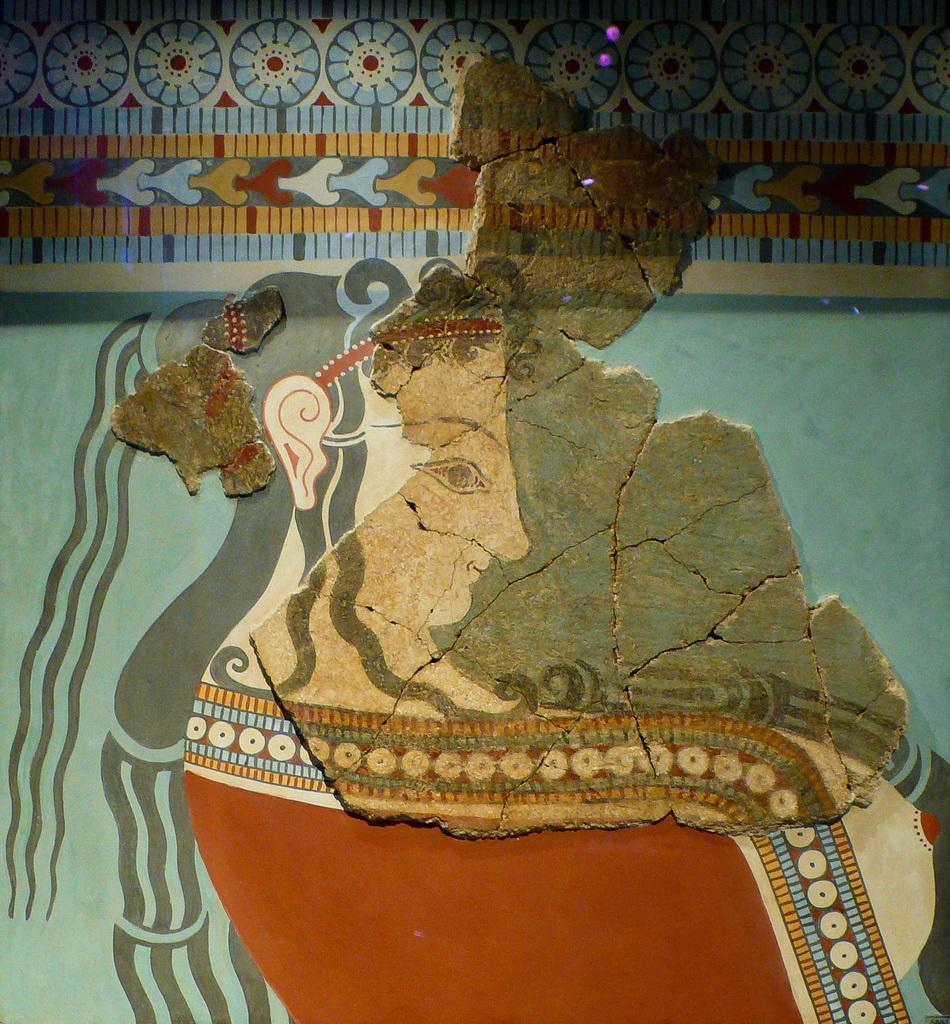In one or two sentences, can you explain what this image depicts? In the image there is painting on women on the wall with design above it. 